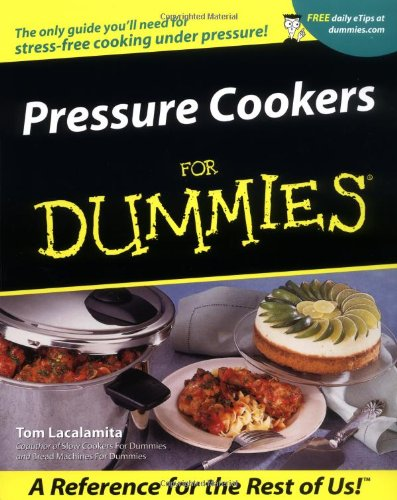Is this a transportation engineering book? No, this book is not related to transportation engineering; rather, it is a culinary guide focused on the use of pressure cookers. 